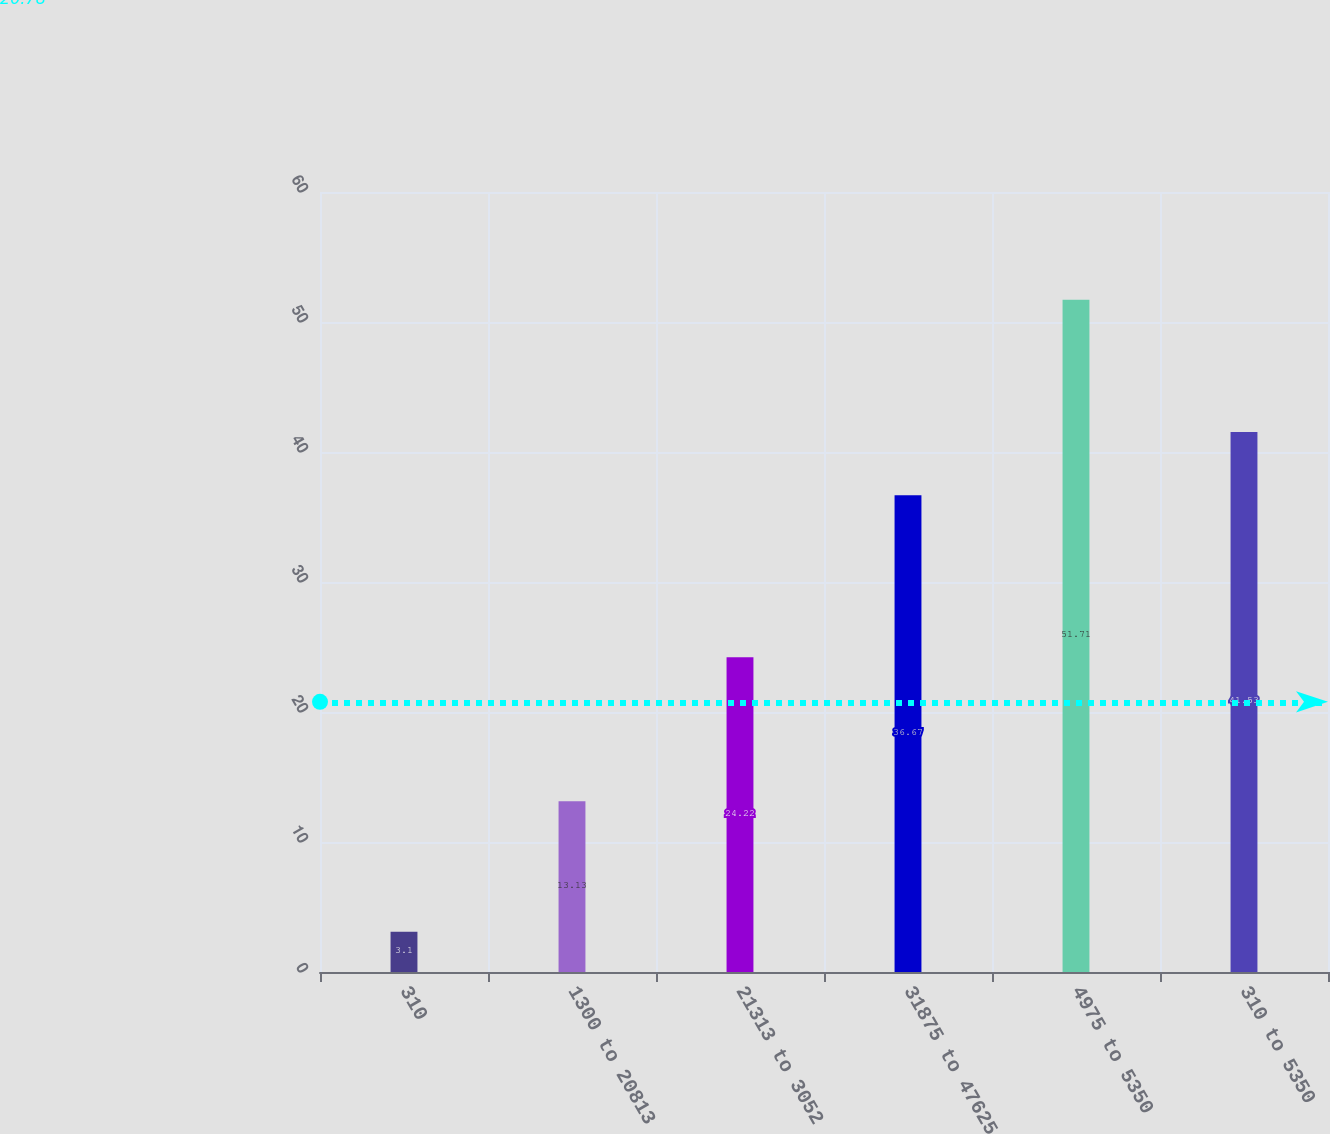Convert chart to OTSL. <chart><loc_0><loc_0><loc_500><loc_500><bar_chart><fcel>310<fcel>1300 to 20813<fcel>21313 to 3052<fcel>31875 to 47625<fcel>4975 to 5350<fcel>310 to 5350<nl><fcel>3.1<fcel>13.13<fcel>24.22<fcel>36.67<fcel>51.71<fcel>41.53<nl></chart> 